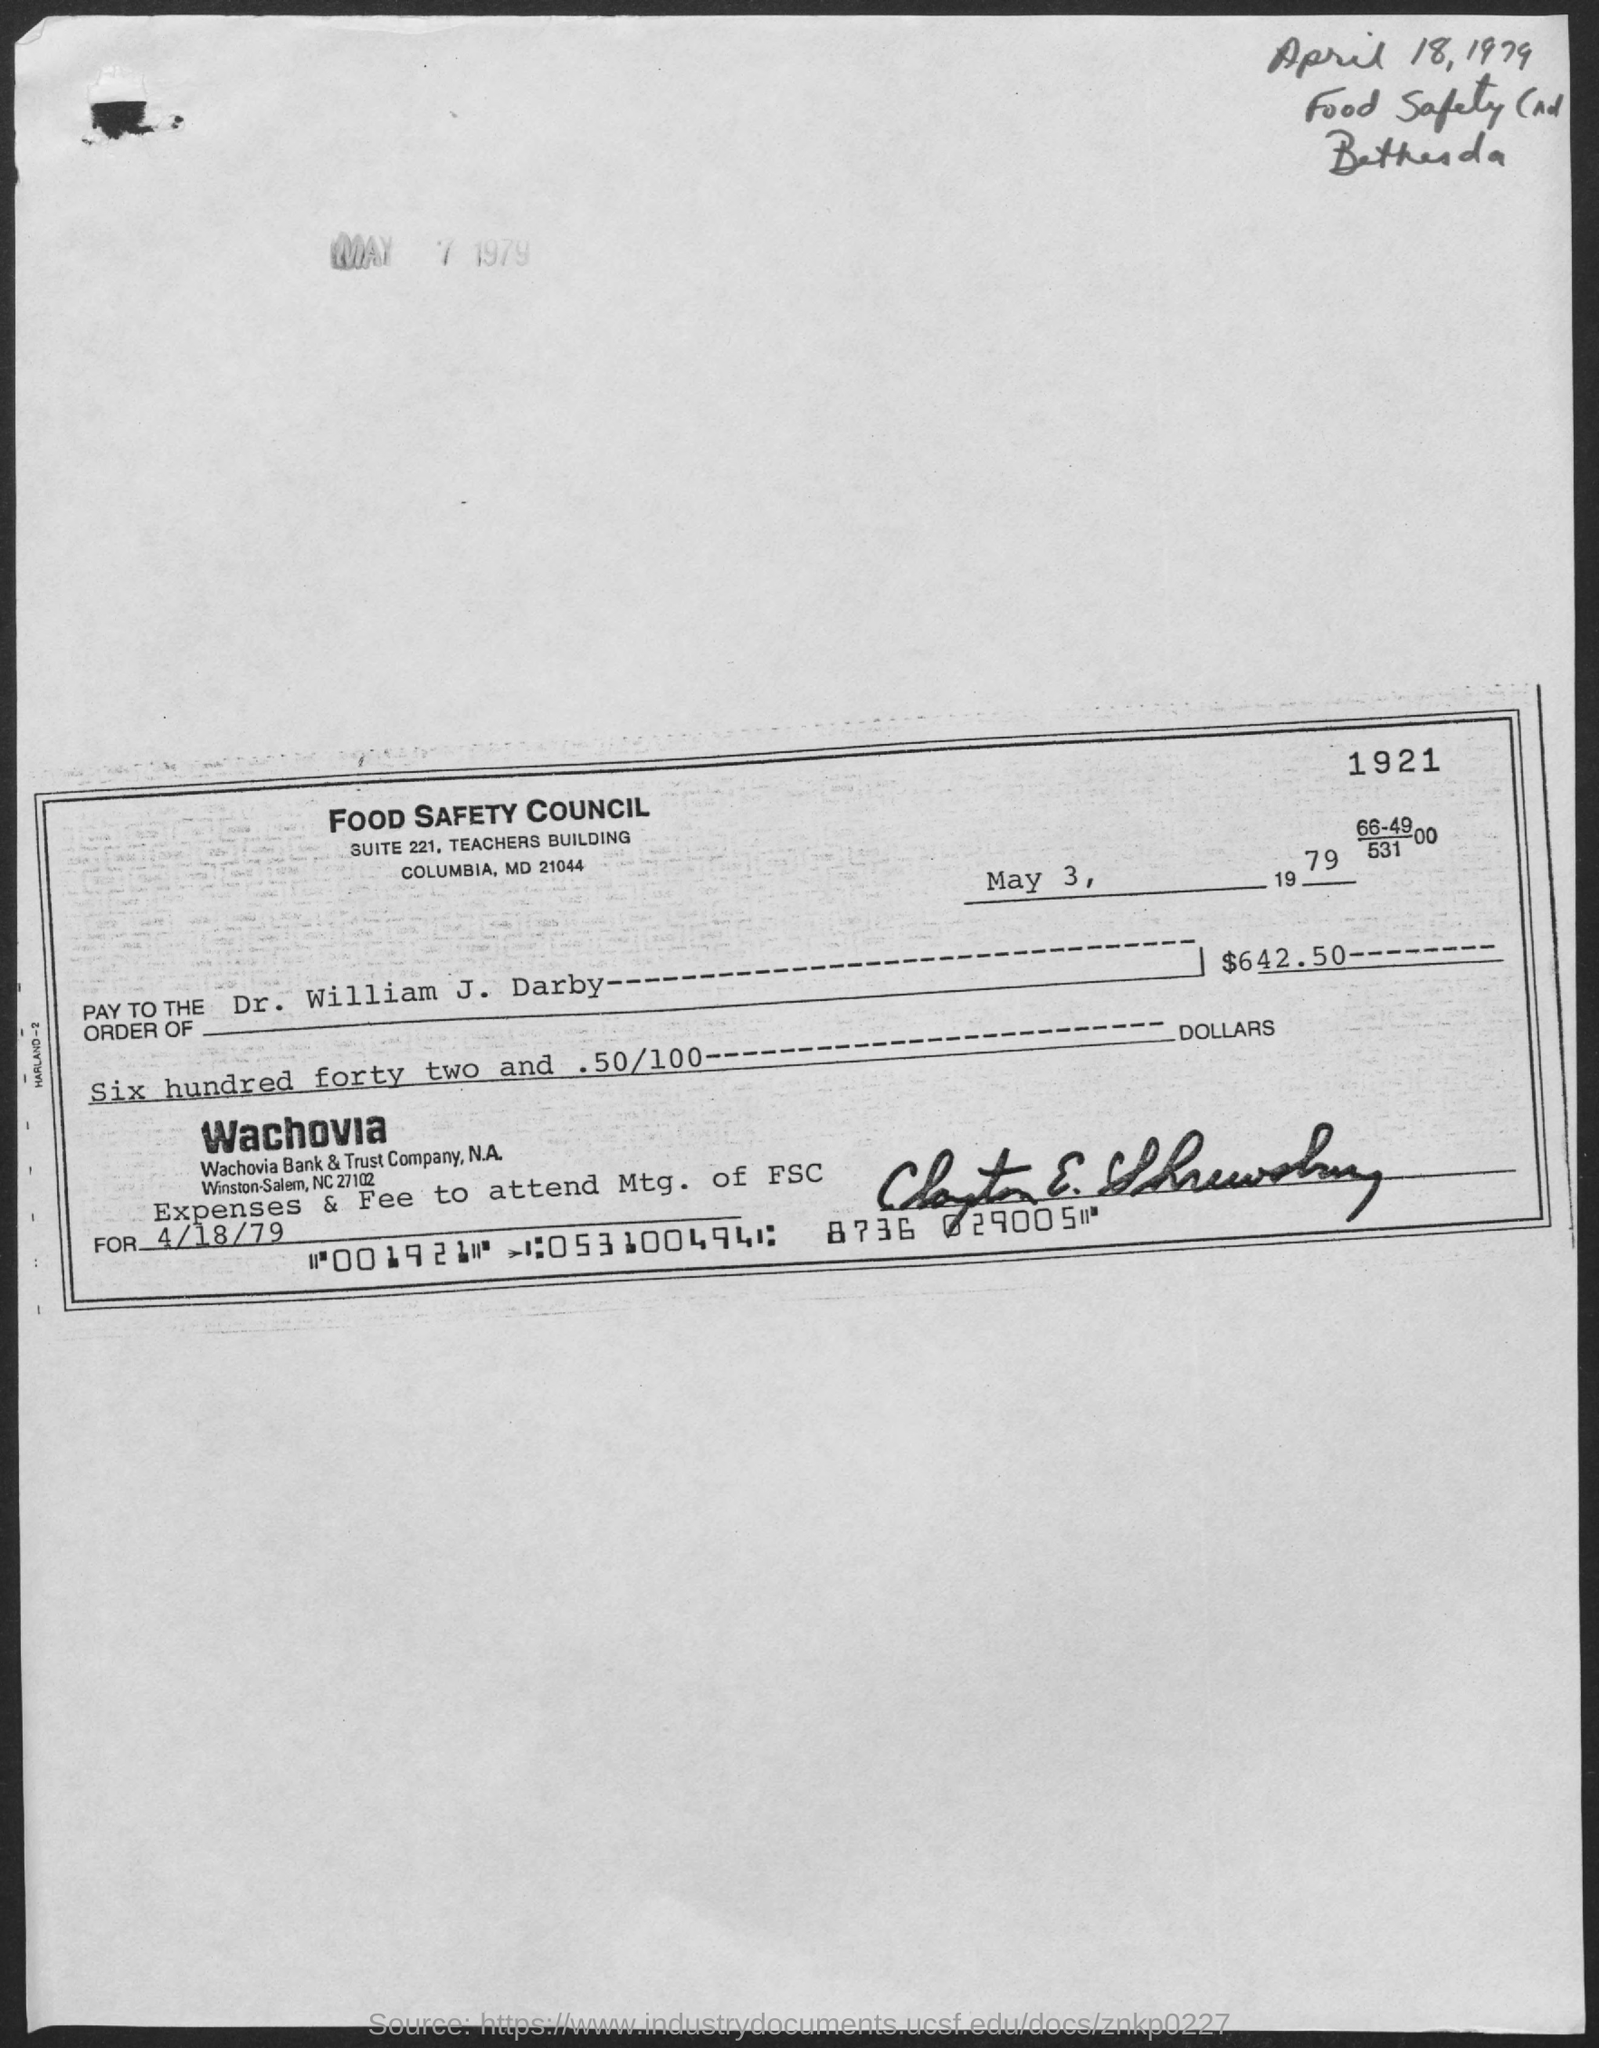Specify some key components in this picture. The amount is $642.50. The date on the check is May 3, 1979. 